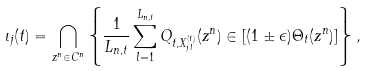<formula> <loc_0><loc_0><loc_500><loc_500>\iota _ { j } ( t ) = \bigcap _ { z ^ { n } \in C ^ { n } } \left \{ \frac { 1 } { L _ { n , t } } \sum _ { l = 1 } ^ { L _ { n , t } } Q _ { t , X ^ { ( t ) } _ { j l } } ( z ^ { n } ) \in [ ( 1 \pm \epsilon ) \Theta _ { t } ( z ^ { n } ) ] \right \} ,</formula> 